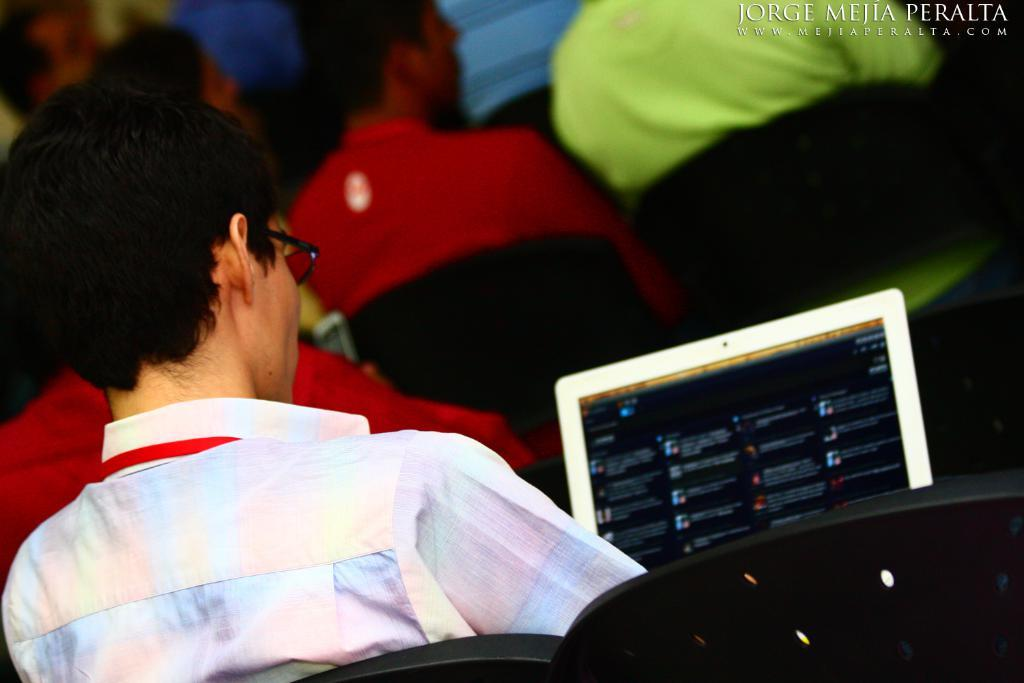What type of furniture is in the foreground of the image? There are black chairs in the foreground of the image. What is the person in the image doing? The person appears to be sitting on the chairs and holding a laptop. Can you describe the setting in the background of the image? In the background, there are other persons sitting. What type of hen can be seen in the image? There is no hen present in the image. Is the dog sitting next to the person in the image? There is no dog present in the image. 